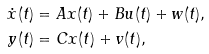Convert formula to latex. <formula><loc_0><loc_0><loc_500><loc_500>\dot { x } ( t ) & = A x ( t ) + B u ( t ) + w ( t ) , \\ y ( t ) & = C x ( t ) + v ( t ) ,</formula> 